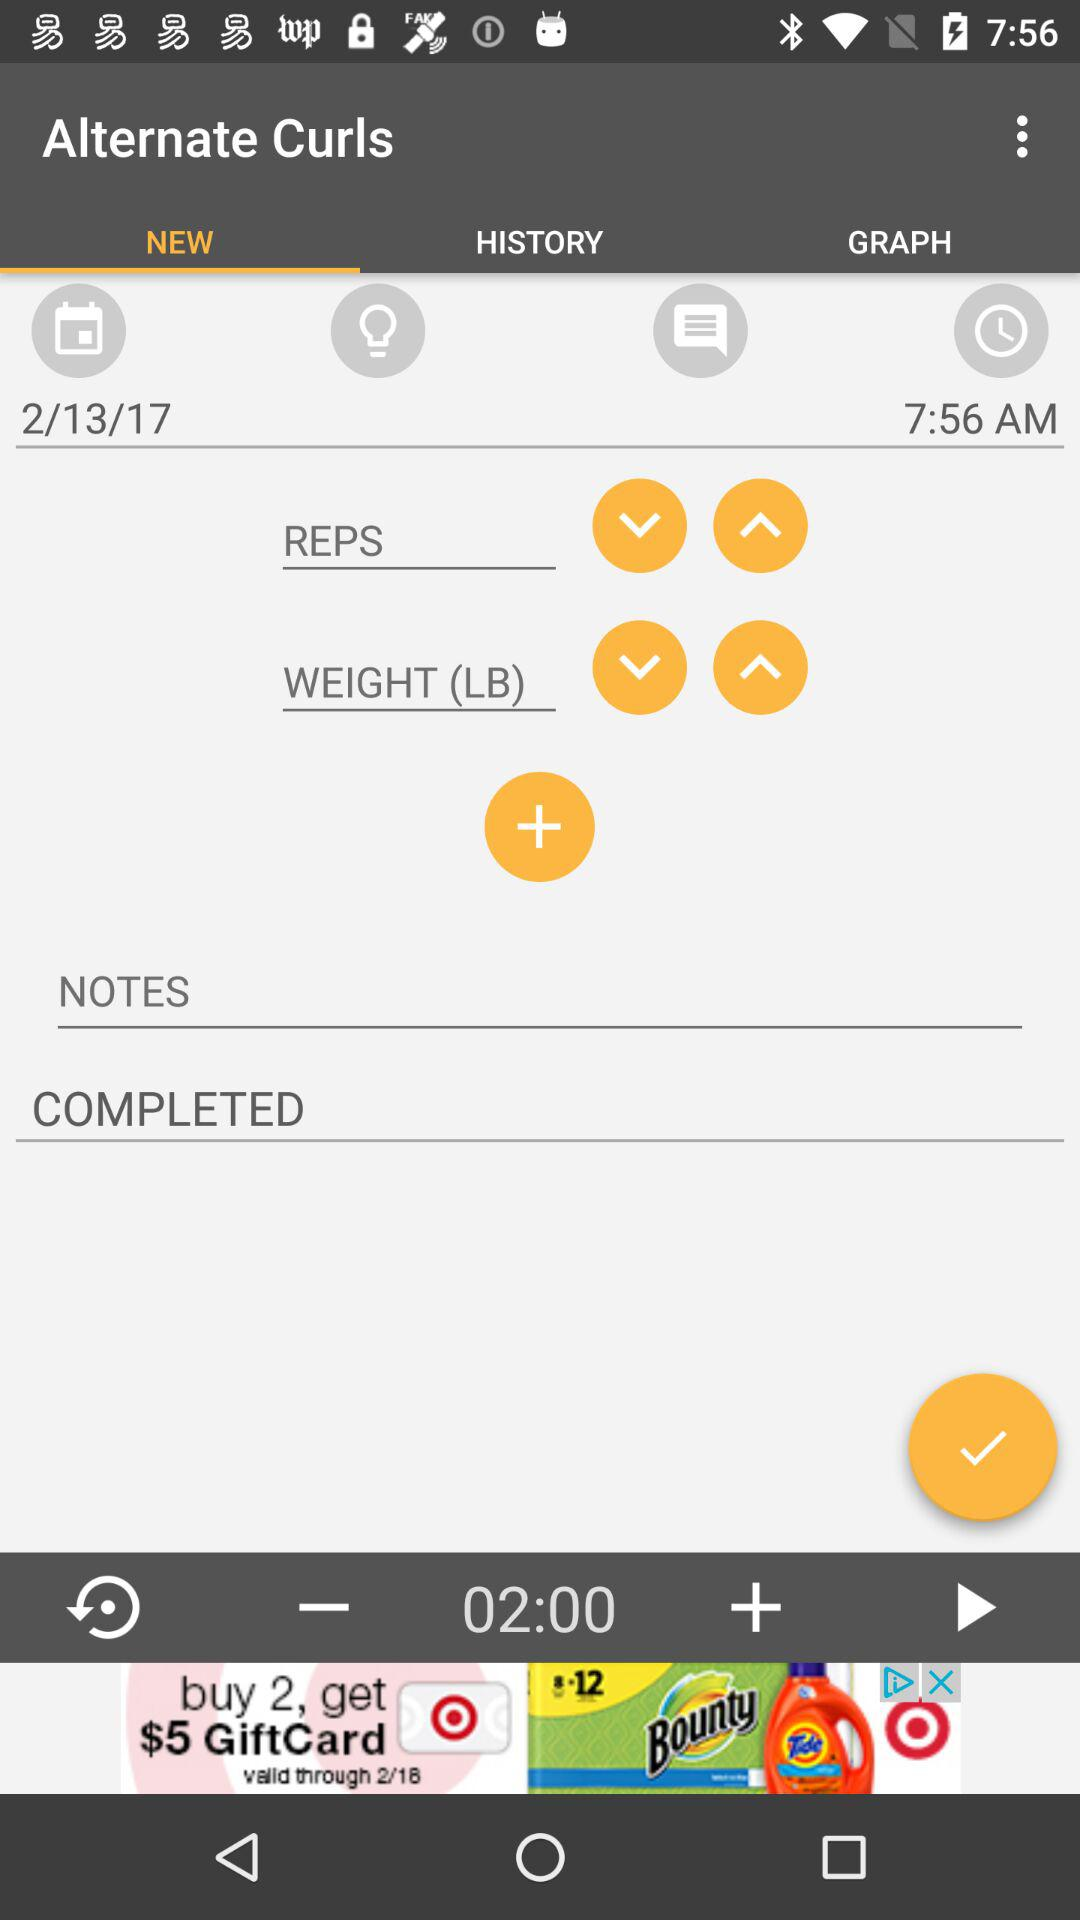What is the date? The date is February 13, 2017. 